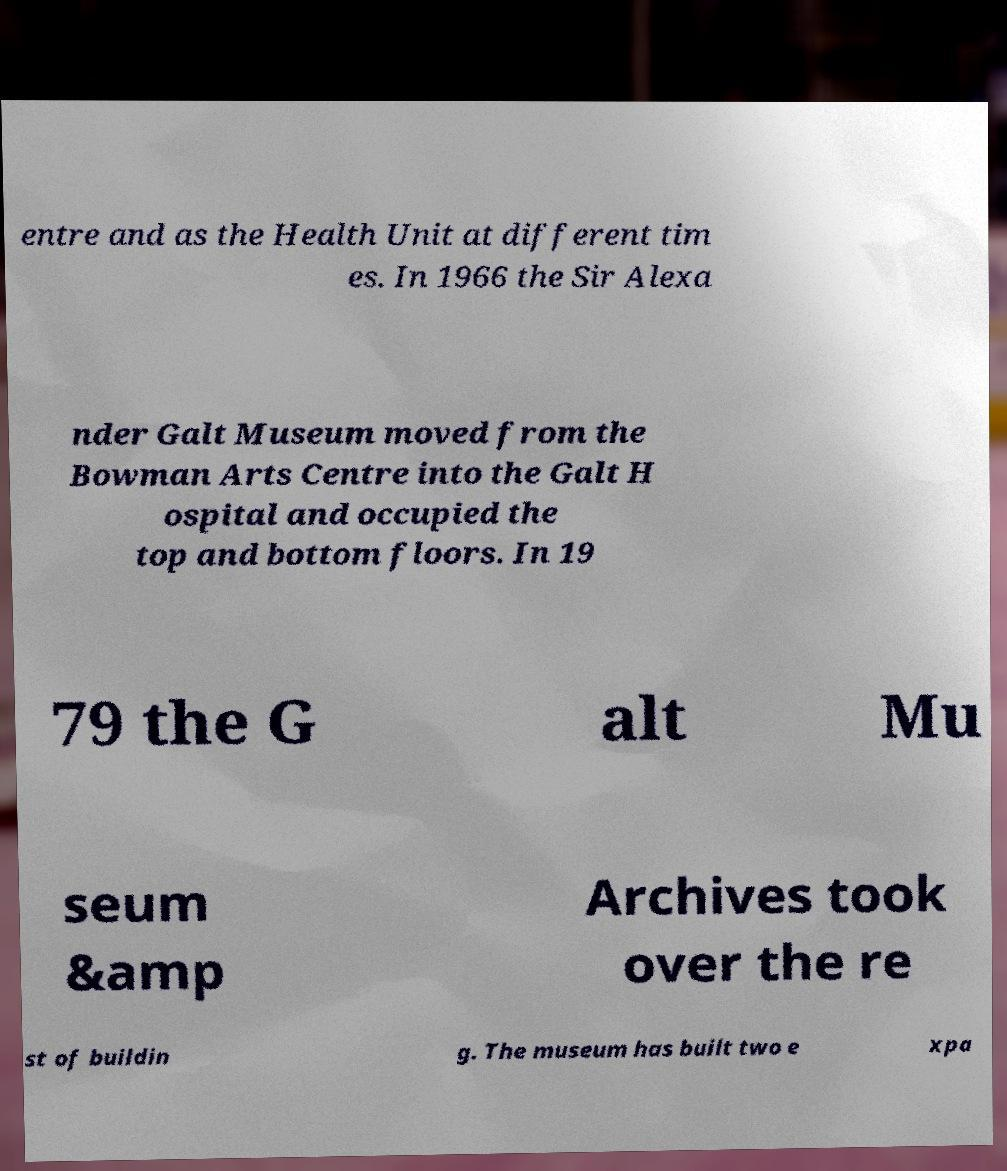Please identify and transcribe the text found in this image. entre and as the Health Unit at different tim es. In 1966 the Sir Alexa nder Galt Museum moved from the Bowman Arts Centre into the Galt H ospital and occupied the top and bottom floors. In 19 79 the G alt Mu seum &amp Archives took over the re st of buildin g. The museum has built two e xpa 